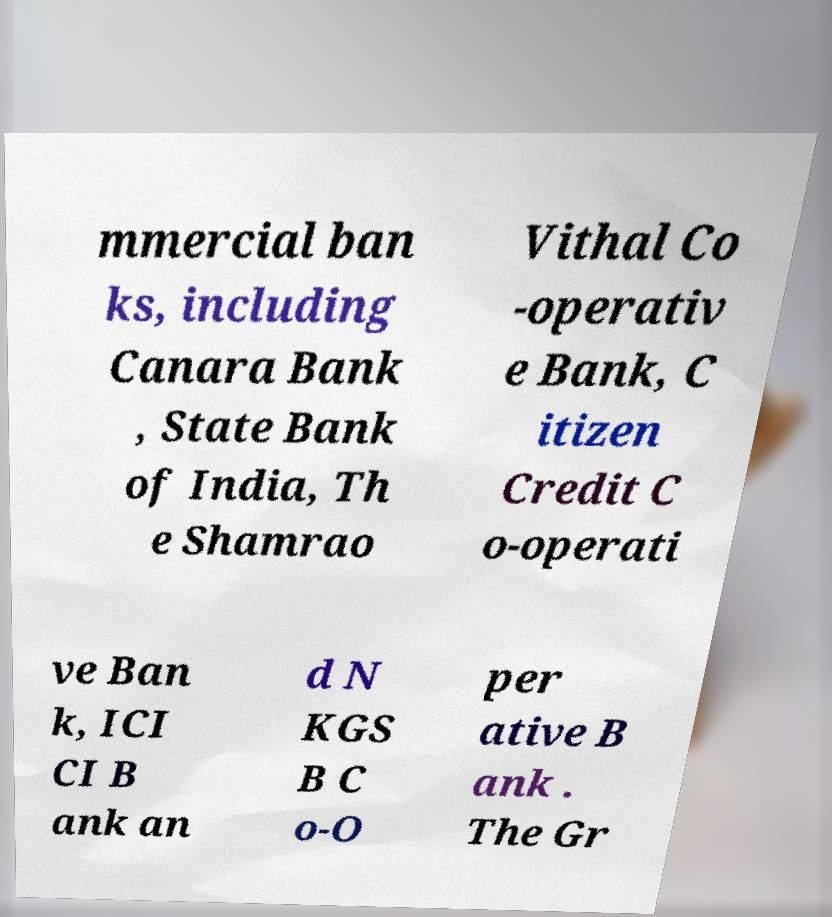Could you extract and type out the text from this image? mmercial ban ks, including Canara Bank , State Bank of India, Th e Shamrao Vithal Co -operativ e Bank, C itizen Credit C o-operati ve Ban k, ICI CI B ank an d N KGS B C o-O per ative B ank . The Gr 